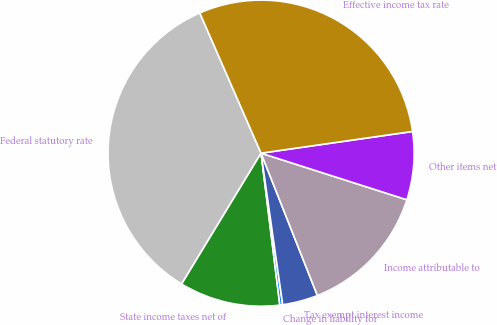<chart> <loc_0><loc_0><loc_500><loc_500><pie_chart><fcel>Federal statutory rate<fcel>State income taxes net of<fcel>Change in liability for<fcel>Tax exempt interest income<fcel>Income attributable to<fcel>Other items net<fcel>Effective income tax rate<nl><fcel>34.76%<fcel>10.64%<fcel>0.3%<fcel>3.74%<fcel>14.08%<fcel>7.19%<fcel>29.29%<nl></chart> 